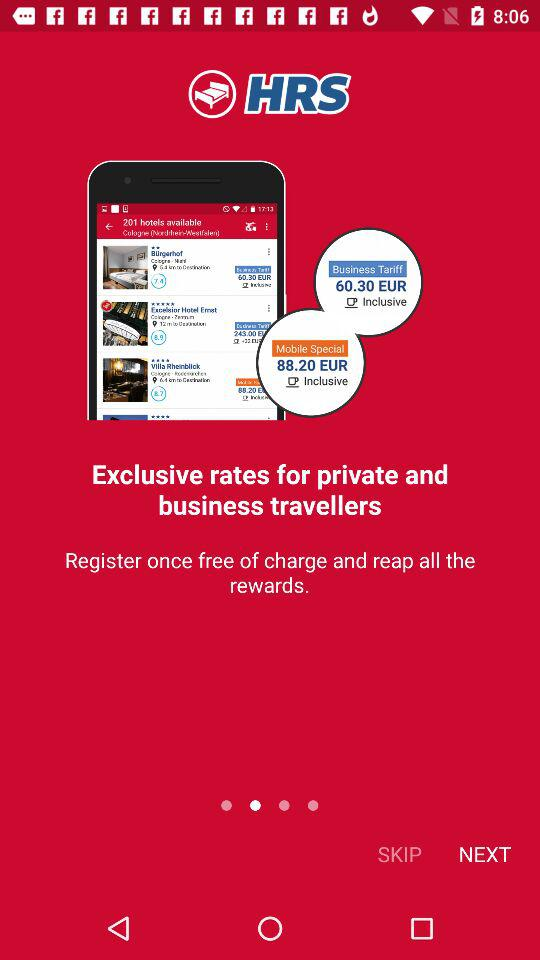What is the name of the application? The name of the application is "HRS". 